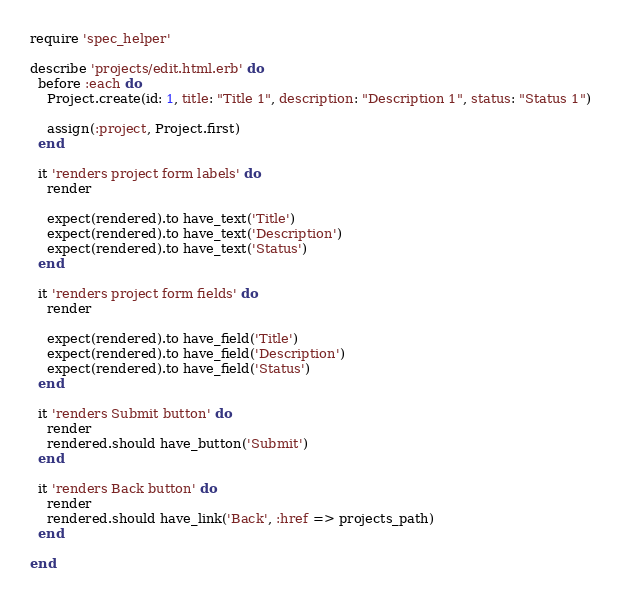Convert code to text. <code><loc_0><loc_0><loc_500><loc_500><_Ruby_>require 'spec_helper'

describe 'projects/edit.html.erb' do
  before :each do
    Project.create(id: 1, title: "Title 1", description: "Description 1", status: "Status 1")

    assign(:project, Project.first)
  end

  it 'renders project form labels' do
    render

    expect(rendered).to have_text('Title')
    expect(rendered).to have_text('Description')
    expect(rendered).to have_text('Status')
  end

  it 'renders project form fields' do
    render

    expect(rendered).to have_field('Title')
    expect(rendered).to have_field('Description')
    expect(rendered).to have_field('Status')
  end

  it 'renders Submit button' do
    render
    rendered.should have_button('Submit')
  end

  it 'renders Back button' do
    render
    rendered.should have_link('Back', :href => projects_path)
  end

end
</code> 